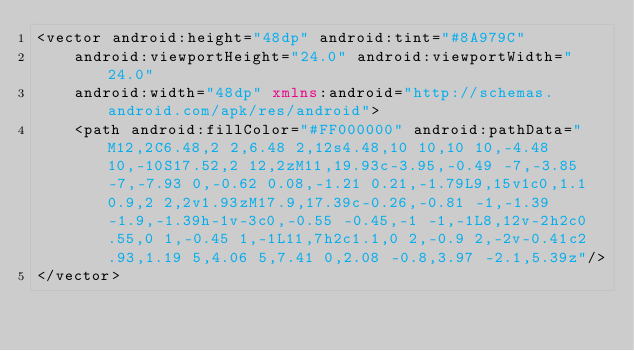<code> <loc_0><loc_0><loc_500><loc_500><_XML_><vector android:height="48dp" android:tint="#8A979C"
    android:viewportHeight="24.0" android:viewportWidth="24.0"
    android:width="48dp" xmlns:android="http://schemas.android.com/apk/res/android">
    <path android:fillColor="#FF000000" android:pathData="M12,2C6.48,2 2,6.48 2,12s4.48,10 10,10 10,-4.48 10,-10S17.52,2 12,2zM11,19.93c-3.95,-0.49 -7,-3.85 -7,-7.93 0,-0.62 0.08,-1.21 0.21,-1.79L9,15v1c0,1.1 0.9,2 2,2v1.93zM17.9,17.39c-0.26,-0.81 -1,-1.39 -1.9,-1.39h-1v-3c0,-0.55 -0.45,-1 -1,-1L8,12v-2h2c0.55,0 1,-0.45 1,-1L11,7h2c1.1,0 2,-0.9 2,-2v-0.41c2.93,1.19 5,4.06 5,7.41 0,2.08 -0.8,3.97 -2.1,5.39z"/>
</vector>
</code> 